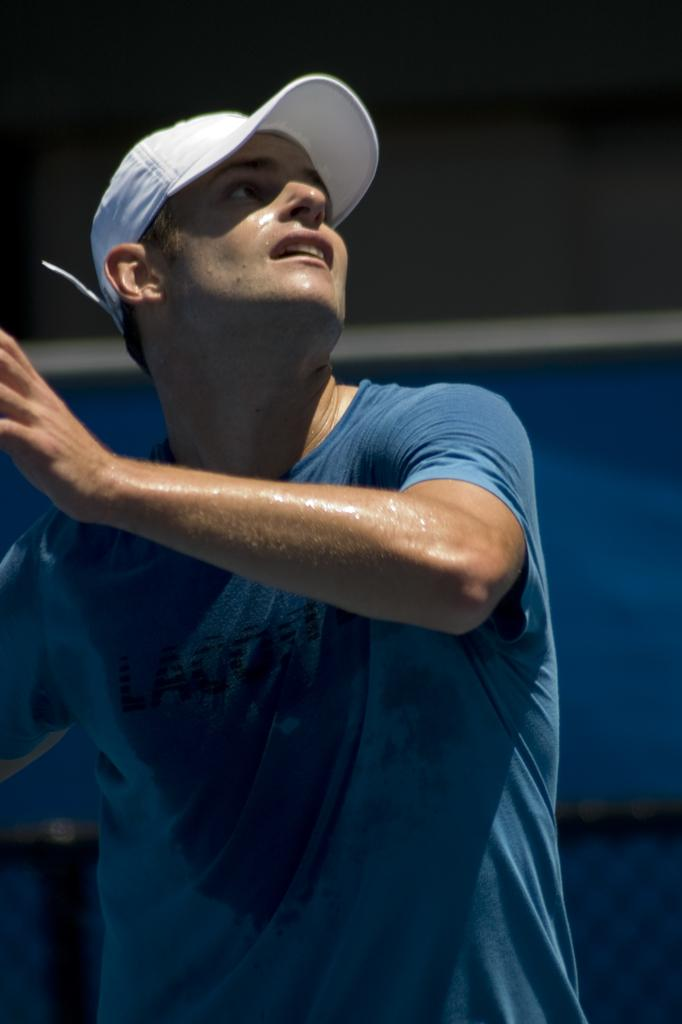What is the main subject of the image? There is a person in the center of the image. What color is the t-shirt that the person is wearing? The person is wearing a blue color t-shirt. What type of headwear is the person wearing? The person is wearing a white color cap. Does the person have wings visible in the image? No, the person does not have wings visible in the image. Can you see a zipper on the t-shirt in the image? No, there is no mention of a zipper on the t-shirt in the provided facts. 